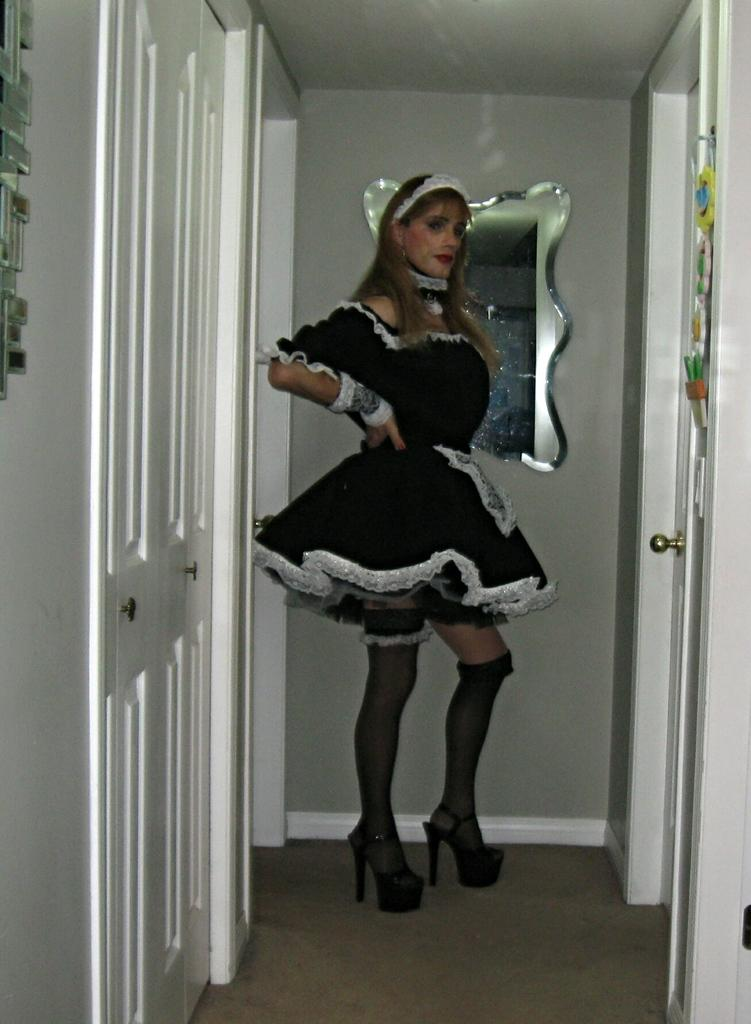Who is the main subject in the image? There is a woman in the middle of the image. What can be seen in the background of the image? There is a mirror in the background of the image. What is located on the left side of the image? There is a door on the left side of the image. What type of expansion is taking place in the image? There is no expansion taking place in the image. Can you see a stove in the image? There is no stove present in the image. 